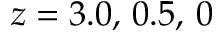Convert formula to latex. <formula><loc_0><loc_0><loc_500><loc_500>z = 3 . 0 , \, 0 . 5 , \, 0</formula> 